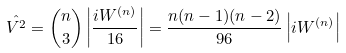<formula> <loc_0><loc_0><loc_500><loc_500>\hat { V ^ { 2 } } = { n \choose 3 } \left | \frac { i W ^ { ( n ) } } { 1 6 } \right | = \frac { n ( n - 1 ) ( n - 2 ) } { 9 6 } \left | i W ^ { ( n ) } \right |</formula> 